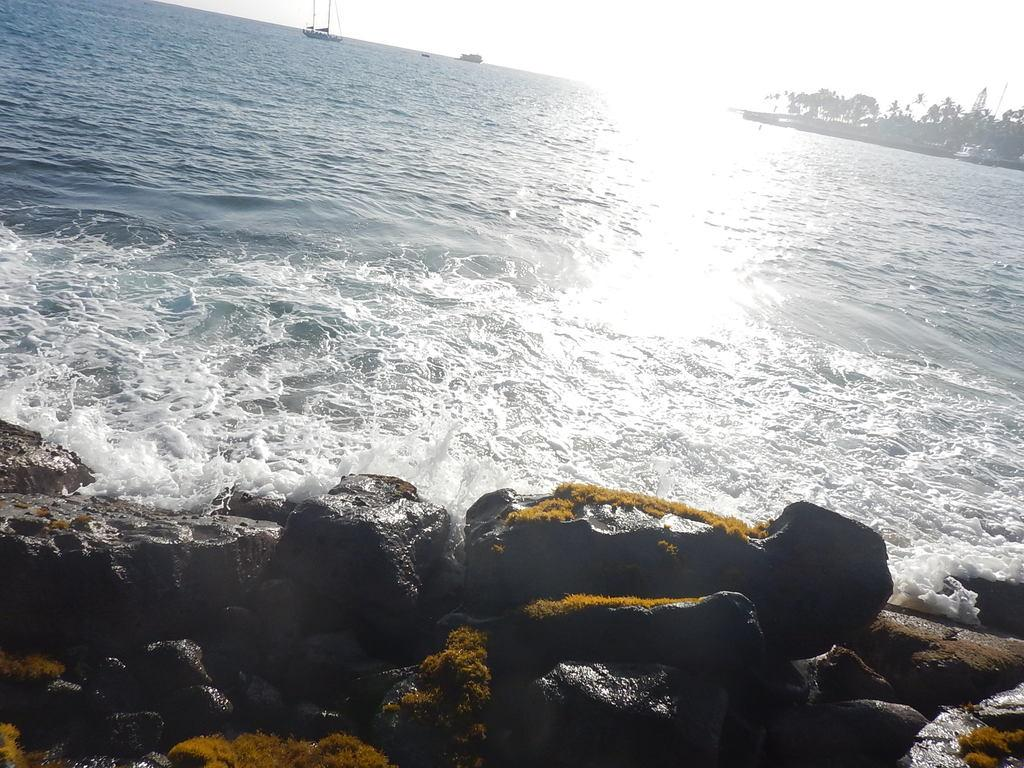What is on the water in the image? There are boats on the water in the image. What else can be seen in the image besides the boats? There are rocks and trees in the image. What is visible in the background of the image? The sky is visible in the background of the image. What shape is the fifth rock in the image? There is no fifth rock in the image, and therefore no shape can be determined for it. 